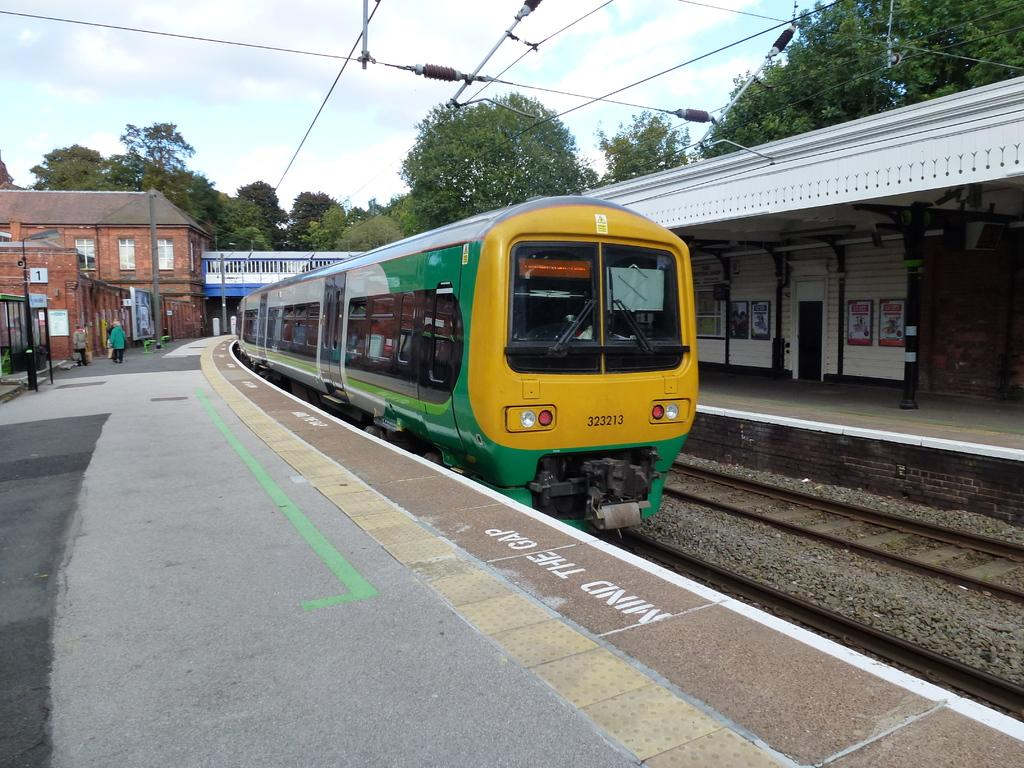<image>
Present a compact description of the photo's key features. the train number 323213 is leaving a station 